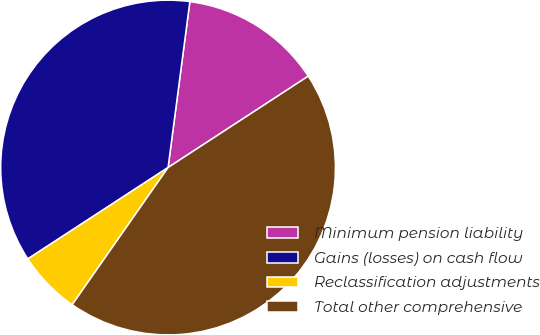<chart> <loc_0><loc_0><loc_500><loc_500><pie_chart><fcel>Minimum pension liability<fcel>Gains (losses) on cash flow<fcel>Reclassification adjustments<fcel>Total other comprehensive<nl><fcel>13.73%<fcel>36.27%<fcel>6.1%<fcel>43.9%<nl></chart> 